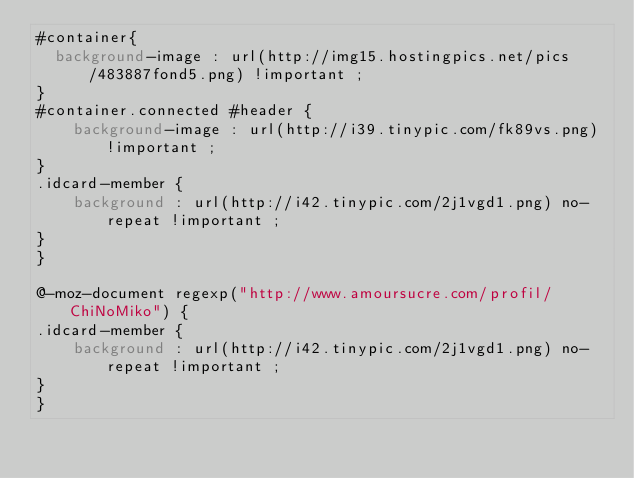Convert code to text. <code><loc_0><loc_0><loc_500><loc_500><_CSS_>#container{
  background-image : url(http://img15.hostingpics.net/pics/483887fond5.png) !important ;
}
#container.connected #header {
    background-image : url(http://i39.tinypic.com/fk89vs.png) !important ;
}
.idcard-member {
    background : url(http://i42.tinypic.com/2j1vgd1.png) no-repeat !important ;
}
}

@-moz-document regexp("http://www.amoursucre.com/profil/ChiNoMiko") {
.idcard-member {
    background : url(http://i42.tinypic.com/2j1vgd1.png) no-repeat !important ;
}
}

</code> 